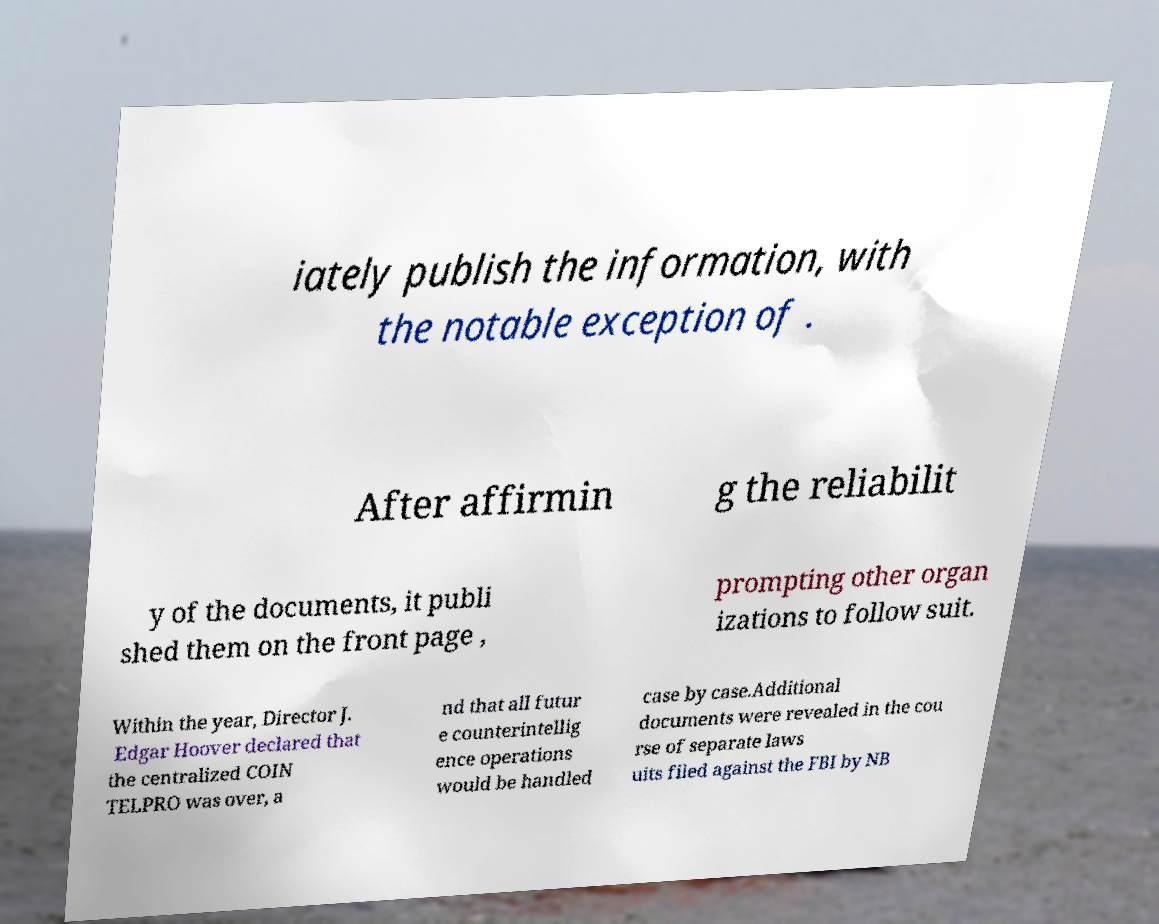I need the written content from this picture converted into text. Can you do that? iately publish the information, with the notable exception of . After affirmin g the reliabilit y of the documents, it publi shed them on the front page , prompting other organ izations to follow suit. Within the year, Director J. Edgar Hoover declared that the centralized COIN TELPRO was over, a nd that all futur e counterintellig ence operations would be handled case by case.Additional documents were revealed in the cou rse of separate laws uits filed against the FBI by NB 